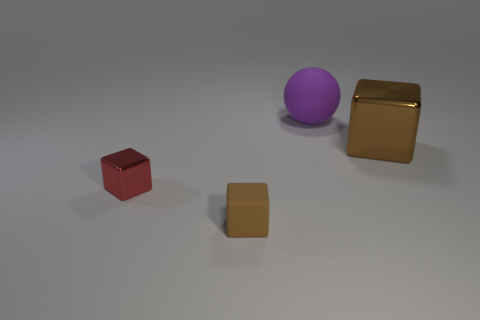Add 4 small cubes. How many objects exist? 8 Subtract all balls. How many objects are left? 3 Subtract 0 red cylinders. How many objects are left? 4 Subtract all big metallic blocks. Subtract all rubber cubes. How many objects are left? 2 Add 3 large brown objects. How many large brown objects are left? 4 Add 1 big cyan things. How many big cyan things exist? 1 